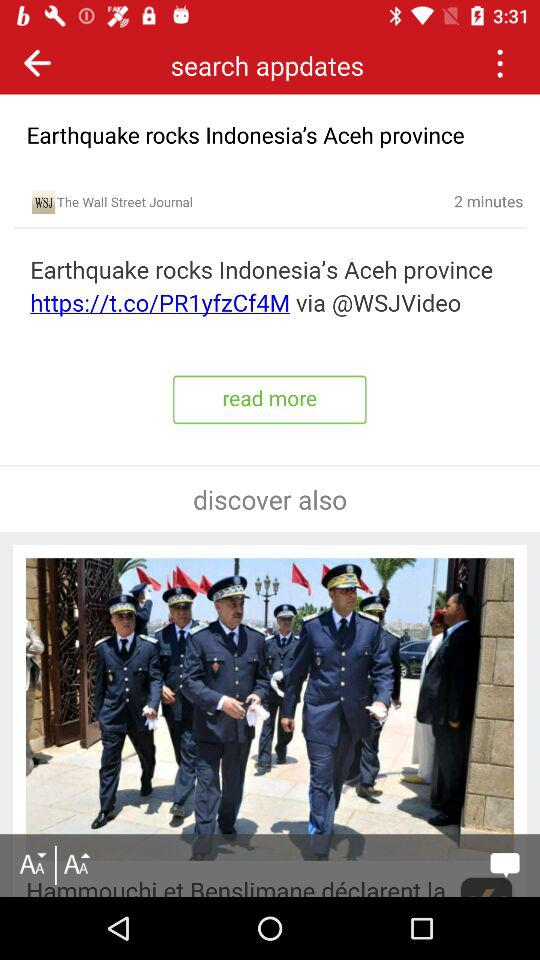When was the post updated? The post was updated 2 minutes ago. 